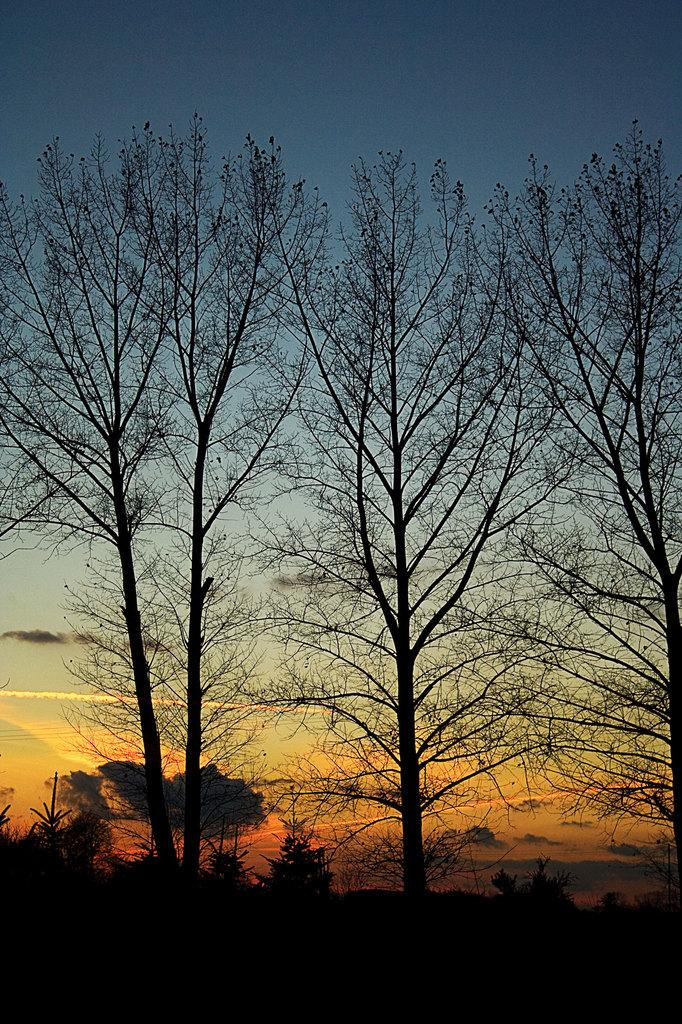What type of vegetation can be seen in the image? There are trees and plants in the image. Where are the plants located in the image? The plants are at the bottom of the image. What can be seen in the background of the image? The sky is visible in the background of the image. What type of bead is hanging from the tree in the image? There is no bead hanging from the tree in the image. Can you describe the bread that the stranger is holding in the image? There is no stranger or bread present in the image. 